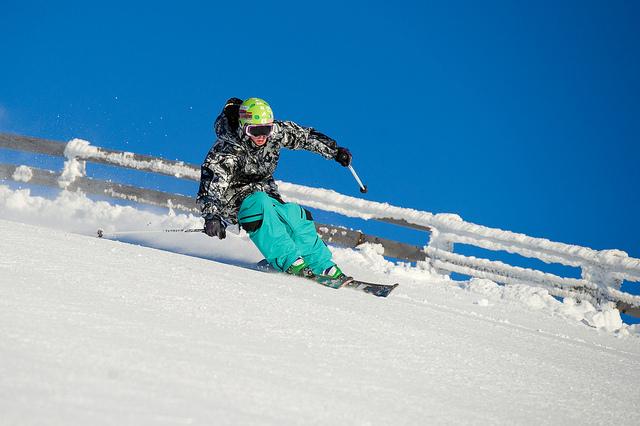Is the skiing in a fenced area?
Give a very brief answer. Yes. What is this person wearing on their hand?
Write a very short answer. Gloves. Is the person wearing a helmet?
Write a very short answer. Yes. 